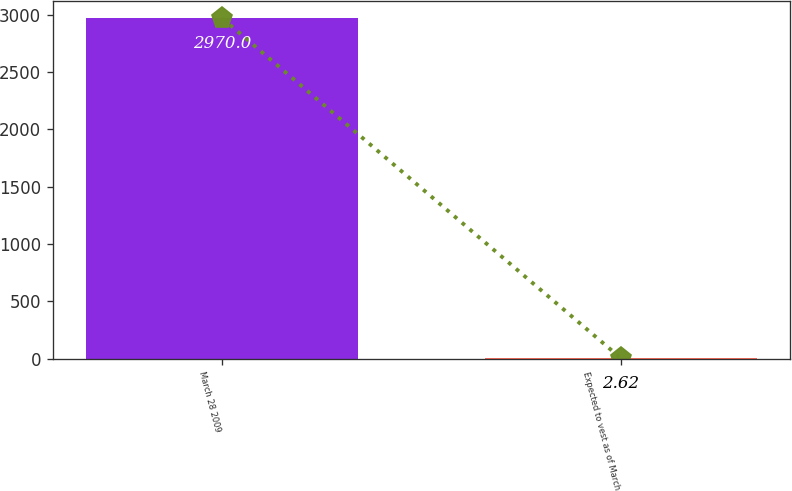Convert chart. <chart><loc_0><loc_0><loc_500><loc_500><bar_chart><fcel>March 28 2009<fcel>Expected to vest as of March<nl><fcel>2970<fcel>2.62<nl></chart> 